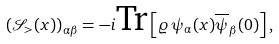<formula> <loc_0><loc_0><loc_500><loc_500>\left ( \mathcal { S } _ { > } ( x ) \right ) _ { \alpha \beta } = - i \text {Tr} \left [ \varrho \, \psi _ { \alpha } ( x ) \overline { \psi } _ { \beta } ( 0 ) \right ] ,</formula> 